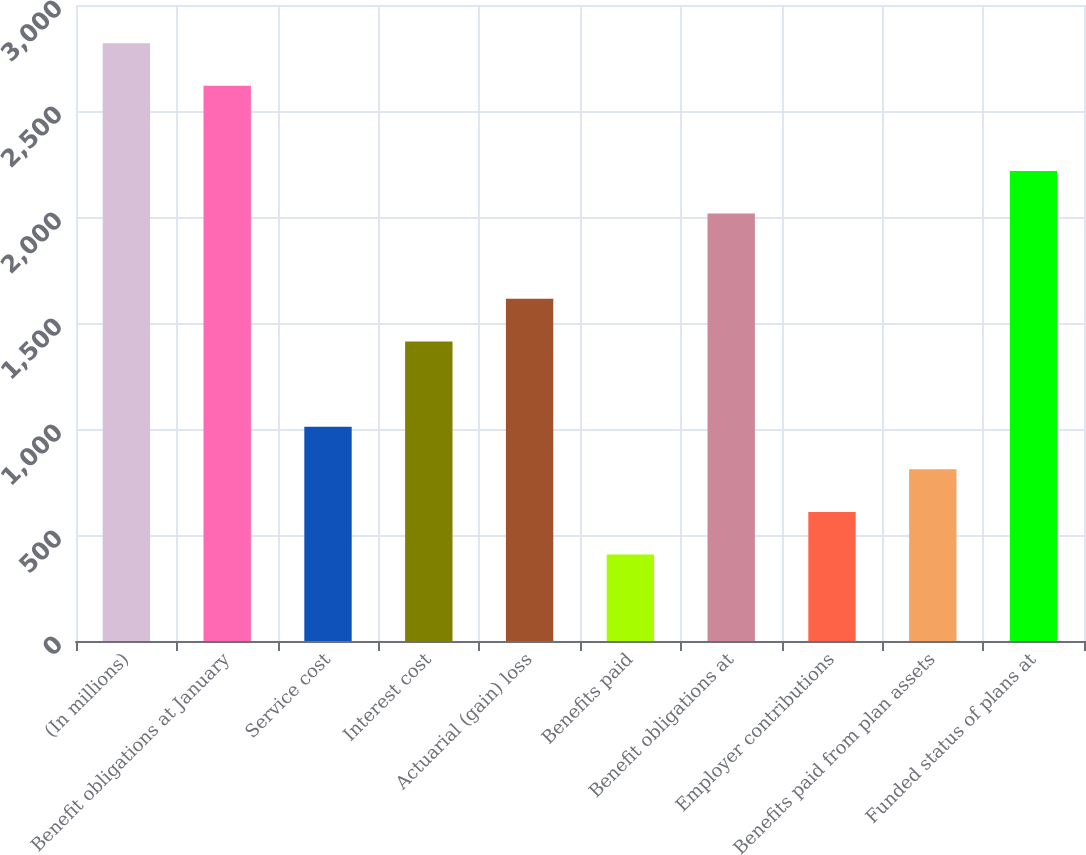<chart> <loc_0><loc_0><loc_500><loc_500><bar_chart><fcel>(In millions)<fcel>Benefit obligations at January<fcel>Service cost<fcel>Interest cost<fcel>Actuarial (gain) loss<fcel>Benefits paid<fcel>Benefit obligations at<fcel>Employer contributions<fcel>Benefits paid from plan assets<fcel>Funded status of plans at<nl><fcel>2820<fcel>2619<fcel>1011<fcel>1413<fcel>1614<fcel>408<fcel>2016<fcel>609<fcel>810<fcel>2217<nl></chart> 